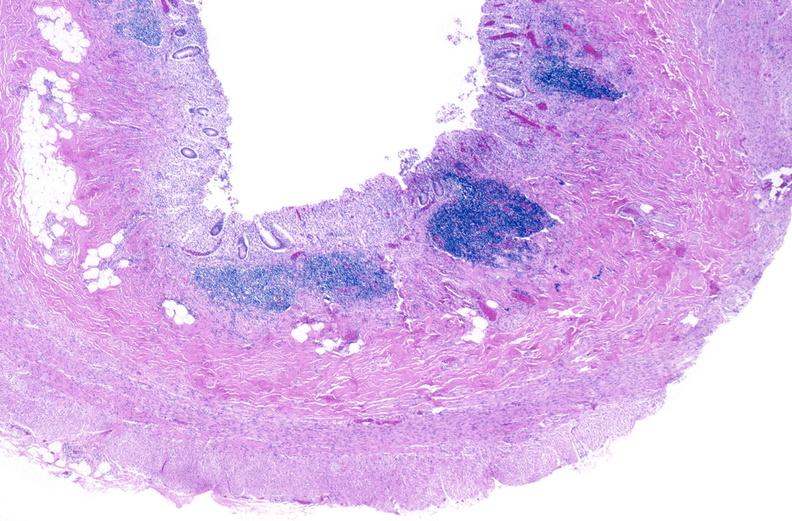where is this from?
Answer the question using a single word or phrase. Gastrointestinal system 